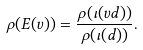<formula> <loc_0><loc_0><loc_500><loc_500>\rho ( E ( v ) ) = \frac { \rho ( \iota ( v d ) ) } { \rho ( \iota ( d ) ) } .</formula> 